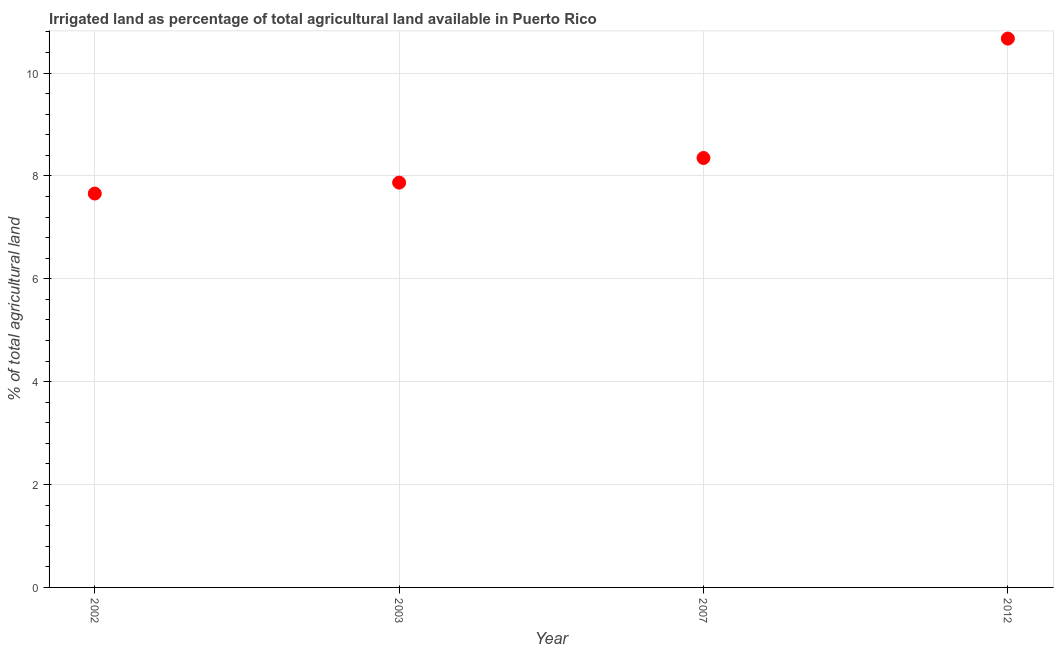What is the percentage of agricultural irrigated land in 2002?
Provide a succinct answer. 7.66. Across all years, what is the maximum percentage of agricultural irrigated land?
Your answer should be very brief. 10.67. Across all years, what is the minimum percentage of agricultural irrigated land?
Ensure brevity in your answer.  7.66. What is the sum of the percentage of agricultural irrigated land?
Provide a short and direct response. 34.55. What is the difference between the percentage of agricultural irrigated land in 2007 and 2012?
Your answer should be very brief. -2.32. What is the average percentage of agricultural irrigated land per year?
Make the answer very short. 8.64. What is the median percentage of agricultural irrigated land?
Your answer should be very brief. 8.11. What is the ratio of the percentage of agricultural irrigated land in 2002 to that in 2003?
Keep it short and to the point. 0.97. Is the percentage of agricultural irrigated land in 2007 less than that in 2012?
Your answer should be compact. Yes. What is the difference between the highest and the second highest percentage of agricultural irrigated land?
Give a very brief answer. 2.32. What is the difference between the highest and the lowest percentage of agricultural irrigated land?
Your answer should be compact. 3.01. In how many years, is the percentage of agricultural irrigated land greater than the average percentage of agricultural irrigated land taken over all years?
Offer a terse response. 1. How many dotlines are there?
Your answer should be very brief. 1. How many years are there in the graph?
Give a very brief answer. 4. What is the difference between two consecutive major ticks on the Y-axis?
Your answer should be compact. 2. Are the values on the major ticks of Y-axis written in scientific E-notation?
Your response must be concise. No. Does the graph contain any zero values?
Give a very brief answer. No. Does the graph contain grids?
Your response must be concise. Yes. What is the title of the graph?
Make the answer very short. Irrigated land as percentage of total agricultural land available in Puerto Rico. What is the label or title of the Y-axis?
Provide a short and direct response. % of total agricultural land. What is the % of total agricultural land in 2002?
Your response must be concise. 7.66. What is the % of total agricultural land in 2003?
Offer a very short reply. 7.87. What is the % of total agricultural land in 2007?
Keep it short and to the point. 8.35. What is the % of total agricultural land in 2012?
Offer a very short reply. 10.67. What is the difference between the % of total agricultural land in 2002 and 2003?
Provide a short and direct response. -0.21. What is the difference between the % of total agricultural land in 2002 and 2007?
Ensure brevity in your answer.  -0.69. What is the difference between the % of total agricultural land in 2002 and 2012?
Provide a short and direct response. -3.01. What is the difference between the % of total agricultural land in 2003 and 2007?
Offer a very short reply. -0.48. What is the difference between the % of total agricultural land in 2003 and 2012?
Provide a short and direct response. -2.8. What is the difference between the % of total agricultural land in 2007 and 2012?
Keep it short and to the point. -2.32. What is the ratio of the % of total agricultural land in 2002 to that in 2003?
Keep it short and to the point. 0.97. What is the ratio of the % of total agricultural land in 2002 to that in 2007?
Your answer should be very brief. 0.92. What is the ratio of the % of total agricultural land in 2002 to that in 2012?
Your answer should be very brief. 0.72. What is the ratio of the % of total agricultural land in 2003 to that in 2007?
Your response must be concise. 0.94. What is the ratio of the % of total agricultural land in 2003 to that in 2012?
Ensure brevity in your answer.  0.74. What is the ratio of the % of total agricultural land in 2007 to that in 2012?
Keep it short and to the point. 0.78. 